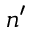<formula> <loc_0><loc_0><loc_500><loc_500>n ^ { \prime }</formula> 